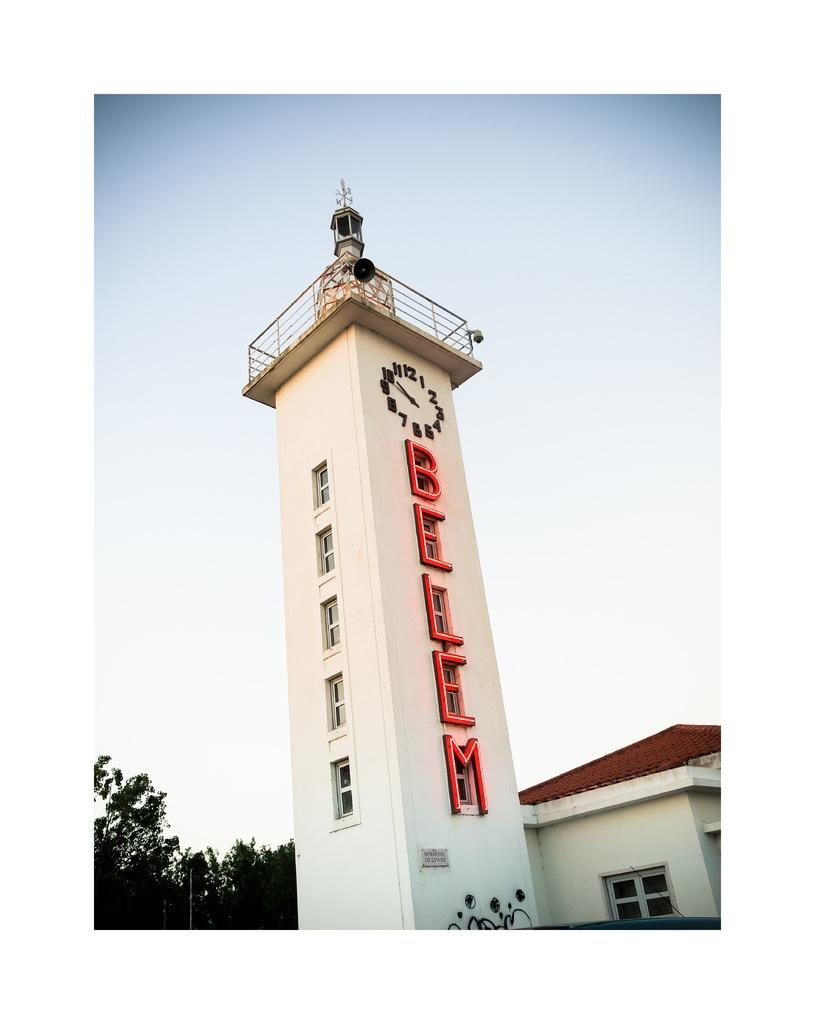What is the main structure in the image? There is a tower in the image. What feature is present in the tower? There is a clock and an LED display in the tower. What can be observed about the tower's design? The tower has windows. What other structures are visible in the image? There is a house beside the tower. What type of vegetation is present in the image? There is a tree in the image. What is visible at the top of the image? The sky is visible at the top of the image. What color is the crayon used to draw the committee meeting in the image? There is no crayon or committee meeting depicted in the image; it features a tower, a house, a tree, and the sky. 